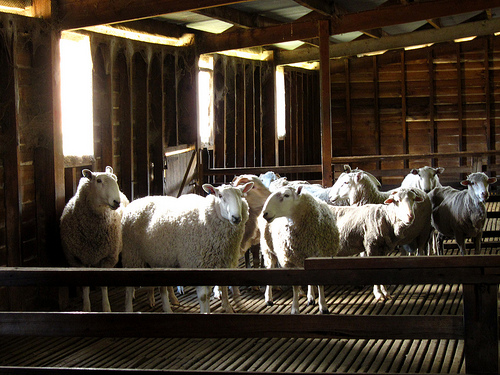<image>
Can you confirm if the sheep is in front of the fence? No. The sheep is not in front of the fence. The spatial positioning shows a different relationship between these objects. 